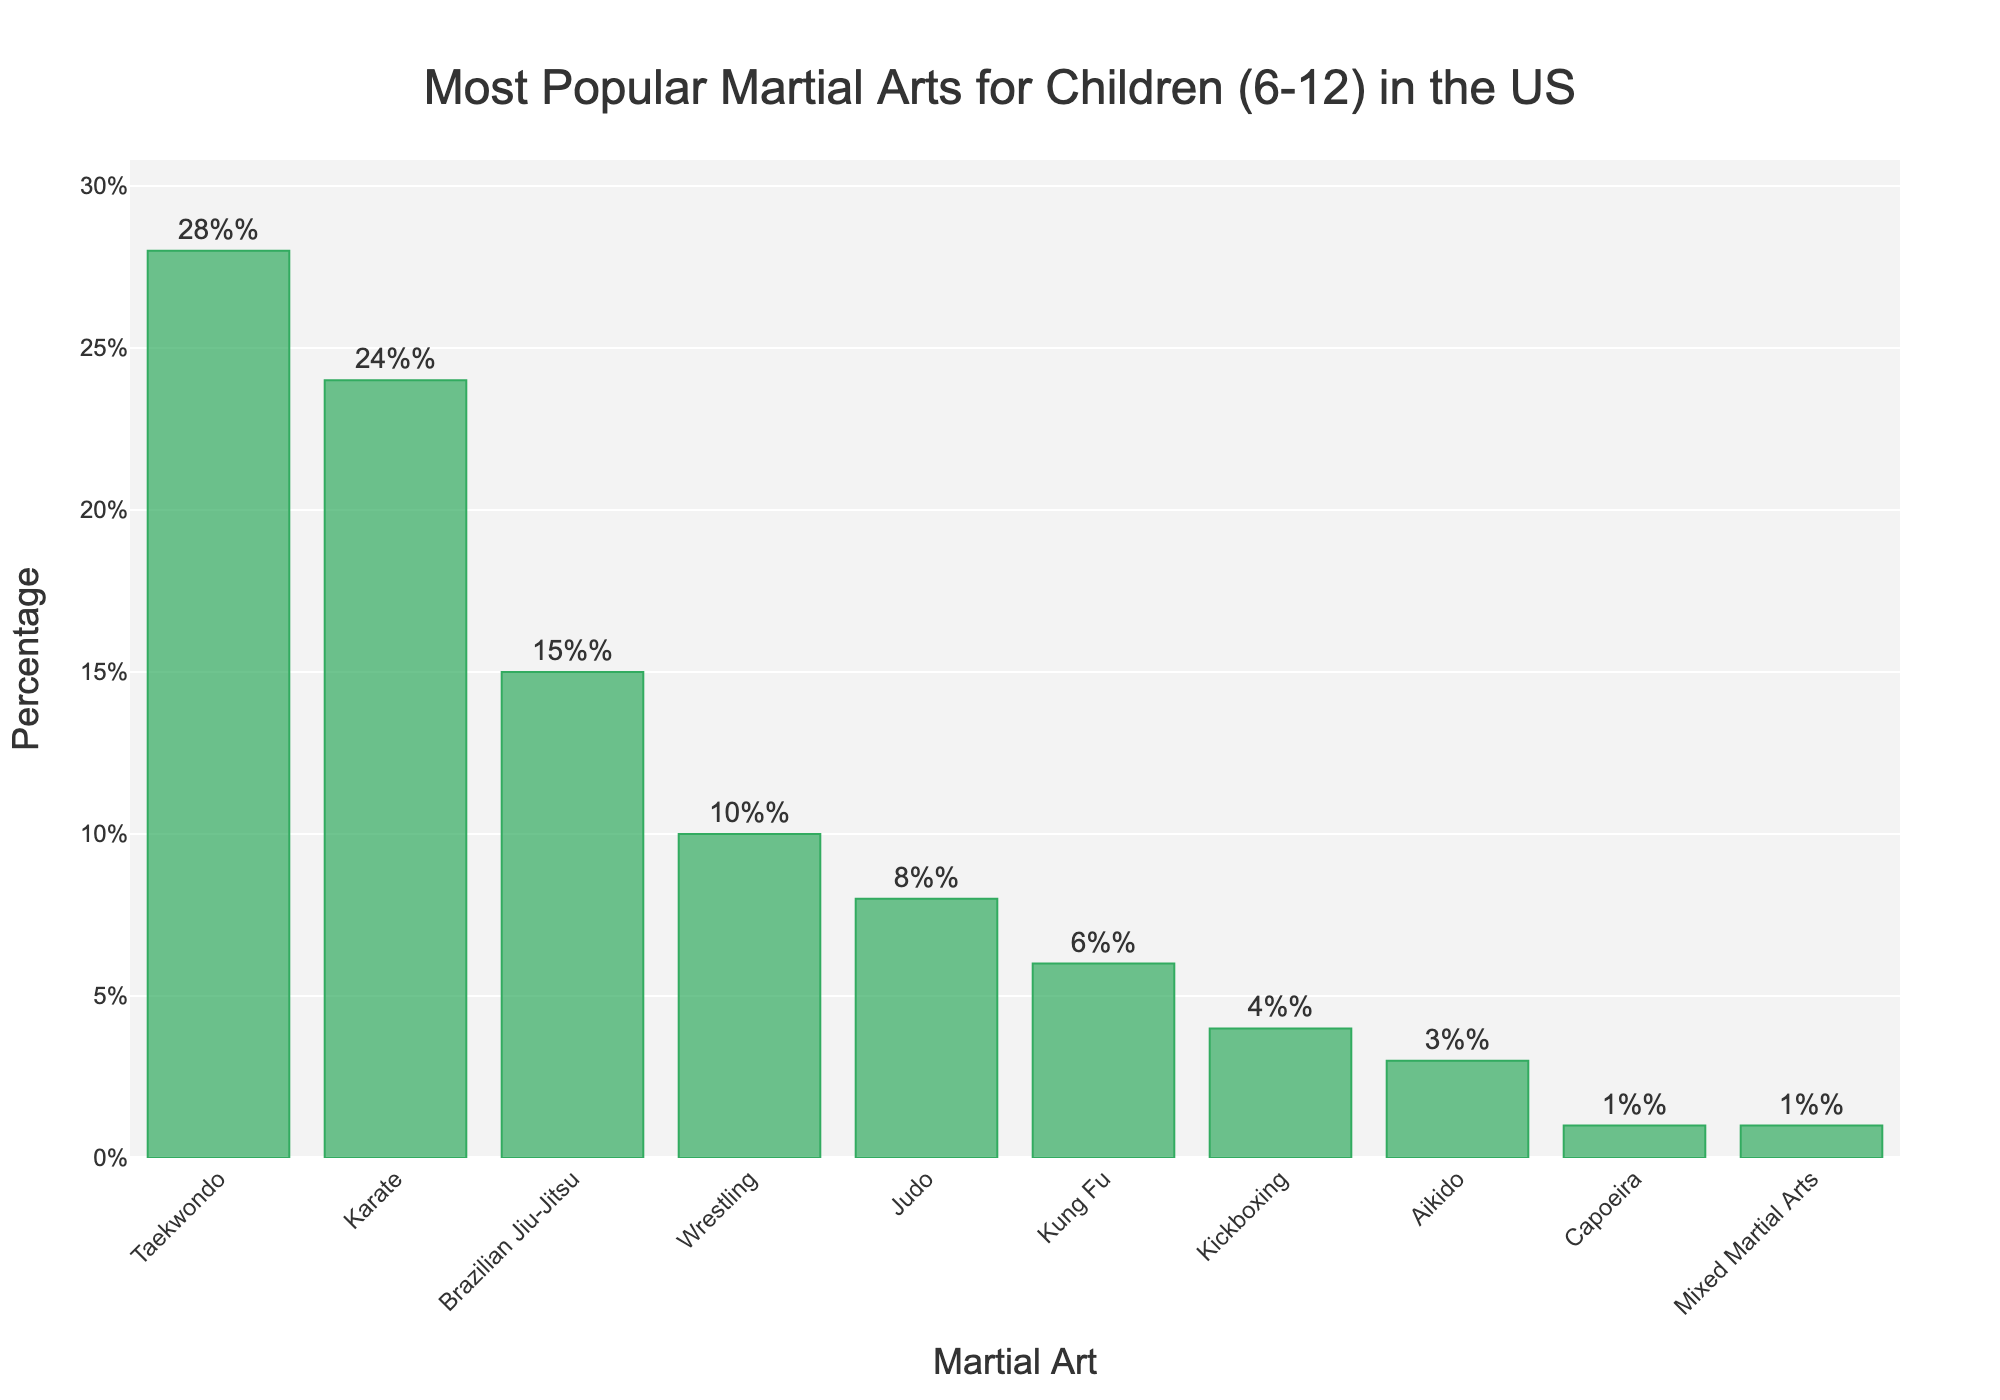What is the most popular martial art for children aged 6-12 in the US? To find the most popular martial art, look for the bar with the highest value. As depicted, Taekwondo has the tallest bar with 28%.
Answer: Taekwondo Which martial art is practiced by 3% of children? Look for the bar that corresponds to 3% on the y-axis. The only martial art at this percentage is Aikido.
Answer: Aikido How does the popularity of Karate compare to Brazilian Jiu-Jitsu? Compare the heights of the bars for Karate and Brazilian Jiu-Jitsu. Karate has a height corresponding to 24%, while Brazilian Jiu-Jitsu is at 15%.
Answer: Karate is more popular What is the combined percentage of children practicing Taekwondo and Karate? Add the percentages for Taekwondo (28%) and Karate (24%). The combined total is 28% + 24% = 52%.
Answer: 52% Which martial arts are practiced by less than 10% of children? Identify the bars that fall below the 10% mark on the y-axis. These are Judo (8%), Kung Fu (6%), Kickboxing (4%), Aikido (3%), Capoeira (1%), and Mixed Martial Arts (1%).
Answer: Judo, Kung Fu, Kickboxing, Aikido, Capoeira, Mixed Martial Arts What is the difference in popularity between Wrestling and Judo? Subtract the percentage for Judo (8%) from the percentage for Wrestling (10%). The difference is 10% - 8% = 2%.
Answer: 2% Which martial art has the shortest bar on the chart? Identify the shortest bar, which corresponds to the lowest percentage. Both Capoeira and Mixed Martial Arts share the shortest bars at 1%.
Answer: Capoeira, Mixed Martial Arts How many martial arts are practiced by more than 5% but less than 20% of children? Count the bars that fall within the 5% to 20% range. These are Brazilian Jiu-Jitsu (15%), Wrestling (10%), and Judo (8%). There are 3 such martial arts.
Answer: 3 Which martial arts have a visual bar color that matches the given color theme (greenish)? All bars in the plot share the same greenish color due to the unified color scheme applied to the chart. Hence, this applies to all listed martial arts.
Answer: All martial arts What is the total percentage of children practicing martial arts that have a higher percentage than Wrestling? Sum the percentages of martial arts with a higher percentage than Wrestling (10%): Taekwondo (28%), Karate (24%), and Brazilian Jiu-Jitsu (15%). The total is 28% + 24% + 15% = 67%.
Answer: 67% 